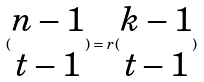Convert formula to latex. <formula><loc_0><loc_0><loc_500><loc_500>( \begin{matrix} n - 1 \\ t - 1 \end{matrix} ) = r ( \begin{matrix} k - 1 \\ t - 1 \end{matrix} )</formula> 